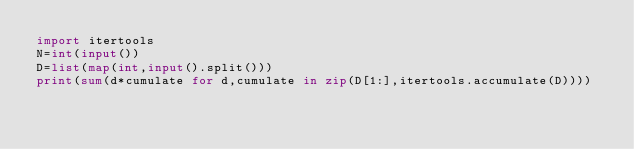Convert code to text. <code><loc_0><loc_0><loc_500><loc_500><_Python_>import itertools
N=int(input())
D=list(map(int,input().split()))
print(sum(d*cumulate for d,cumulate in zip(D[1:],itertools.accumulate(D))))</code> 